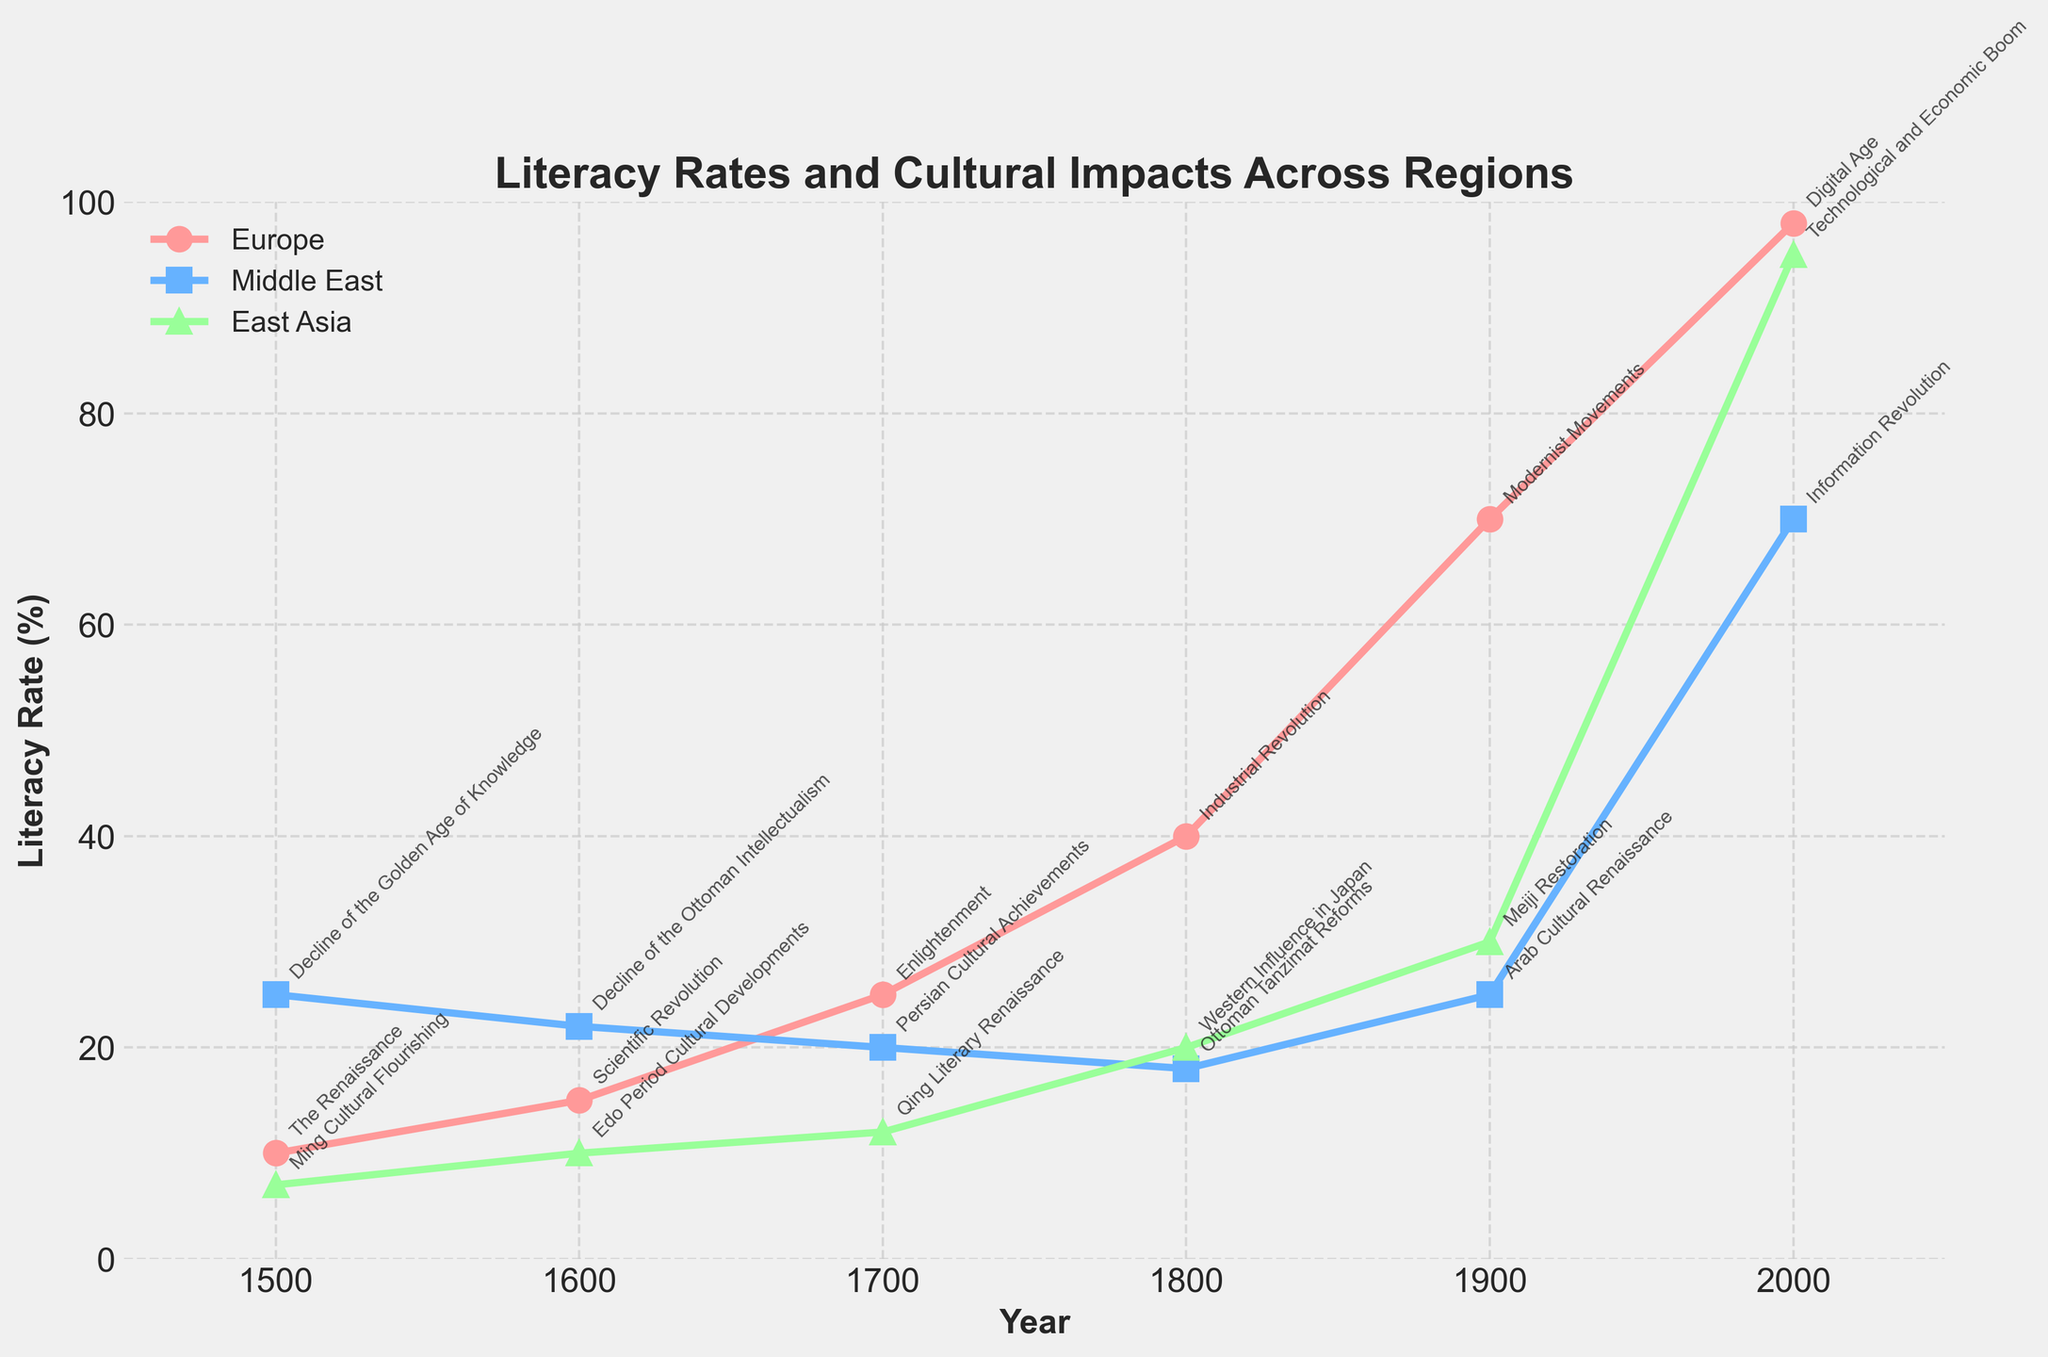What's the highest literacy rate for Europe in the plot? Looking at the plot, the highest literacy rate for Europe is found at the year 2000. The rate shown is 98%.
Answer: 98% Which region had the highest literacy rate in the year 1500? Examining the literacy rates for the year 1500, the Middle East has the highest literacy rate at 25%.
Answer: Middle East How many significant cultural impacts are annotated on the plot? Counting all the annotations for significant cultural impacts in the plot, there are 12 in total.
Answer: 12 By how much did the literacy rate in East Asia increase from 1500 to 2000? The literacy rate in East Asia at 1500 is 7% and at 2000 it is 95%. The increase can be calculated as 95% - 7% = 88%.
Answer: 88% What was the literacy rate in the Middle East during the Enlightenment period in Europe? The Enlightenment period in Europe was around 1700. Looking at the plot for the Middle East in the year 1700, the literacy rate is 20%.
Answer: 20% Which region saw the largest increase in literacy rate from 1800 to 1900? Observing the increases in literacy rates from 1800 to 1900 for each region: Europe increased from 40% to 70% (a 30% increase), the Middle East increased from 18% to 25% (a 7% increase), and East Asia increased from 20% to 30% (a 10% increase). The largest increase is in Europe.
Answer: Europe Between which centuries did Europe experience the largest growth in literacy rate? Reviewing the plot, Europe experienced its largest growth in literacy rate between the 18th century (1700) and 19th century (1800), with the rate increasing from 25% to 40%, a 15% increase.
Answer: Between 1700 and 1800 What were the significant cultural impacts in East Asia and the Middle East around the year 1900? The plot annotates the significant cultural impacts around the year 1900: for East Asia, it is the Meiji Restoration; for the Middle East, it is the Arab Cultural Renaissance.
Answer: Meiji Restoration (East Asia) and Arab Cultural Renaissance (Middle East) What is the trend for literacy rates in Europe from 1500 to 2000? The plot shows that the literacy rate in Europe steadily increases from 10% in 1500 to 98% in 2000.
Answer: Steady increase In which year did the Middle East and East Asia have equal literacy rates? Observing the plot, the literacy rates are equal for the Middle East (25%) and East Asia (25%) in the year 1900.
Answer: 1900 